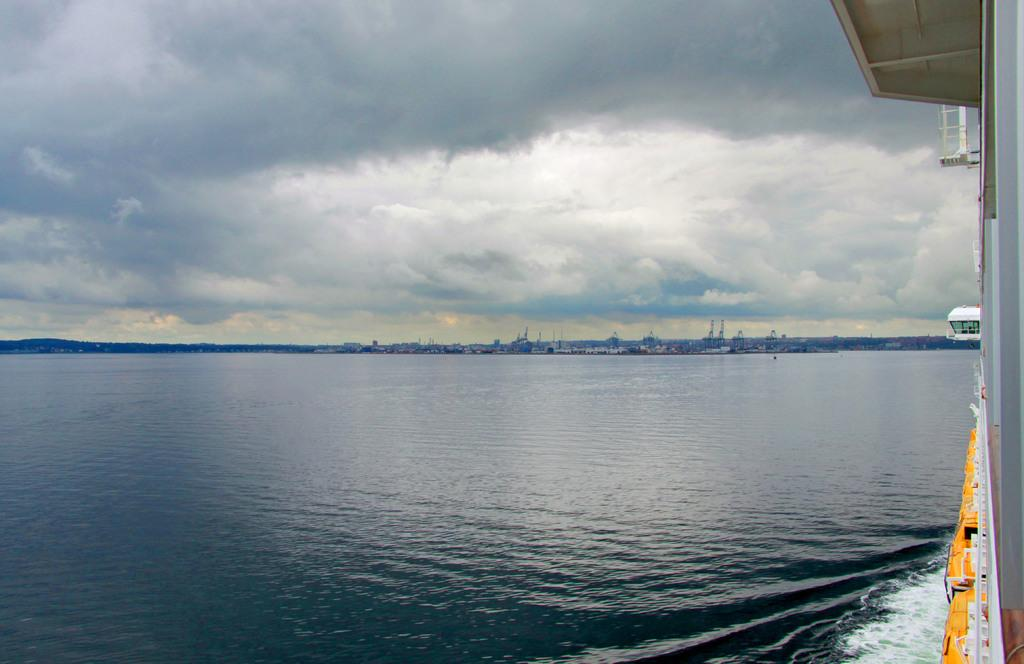What is the primary element in the image? The image consists of water. What can be seen on the right side of the image? There is a boat on the right side of the image. What is visible in the sky at the top of the image? There are clouds visible in the sky at the top of the image. What type of sock is hanging from the boat in the image? There is no sock present in the image; it consists of water, a boat, and clouds in the sky. 